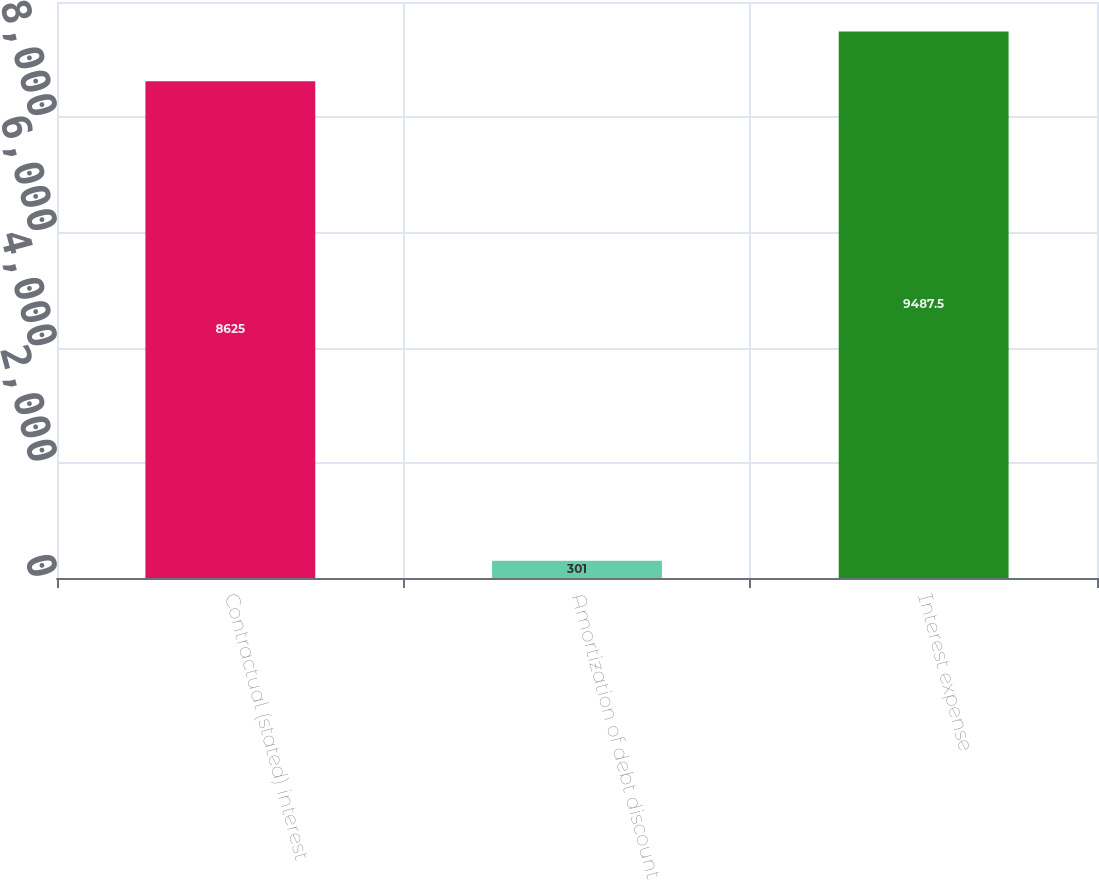Convert chart. <chart><loc_0><loc_0><loc_500><loc_500><bar_chart><fcel>Contractual (stated) interest<fcel>Amortization of debt discount<fcel>Interest expense<nl><fcel>8625<fcel>301<fcel>9487.5<nl></chart> 